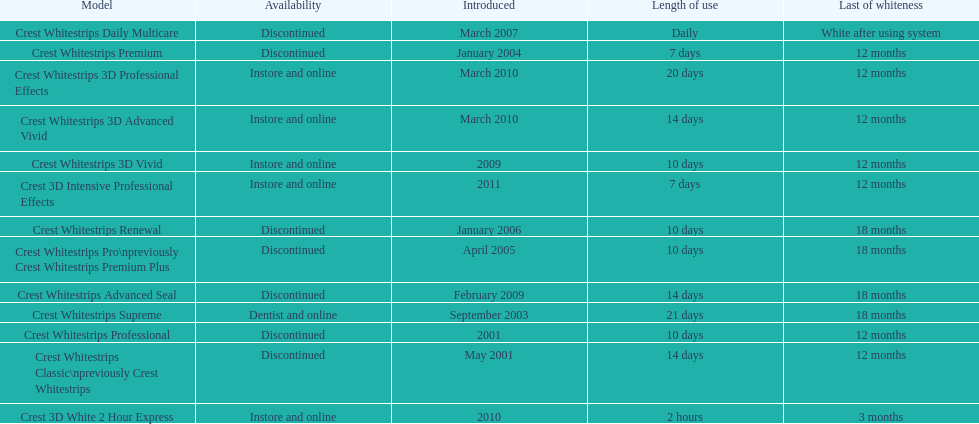What is the number of products that were introduced in 2010? 3. 